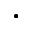<formula> <loc_0><loc_0><loc_500><loc_500>.</formula> 